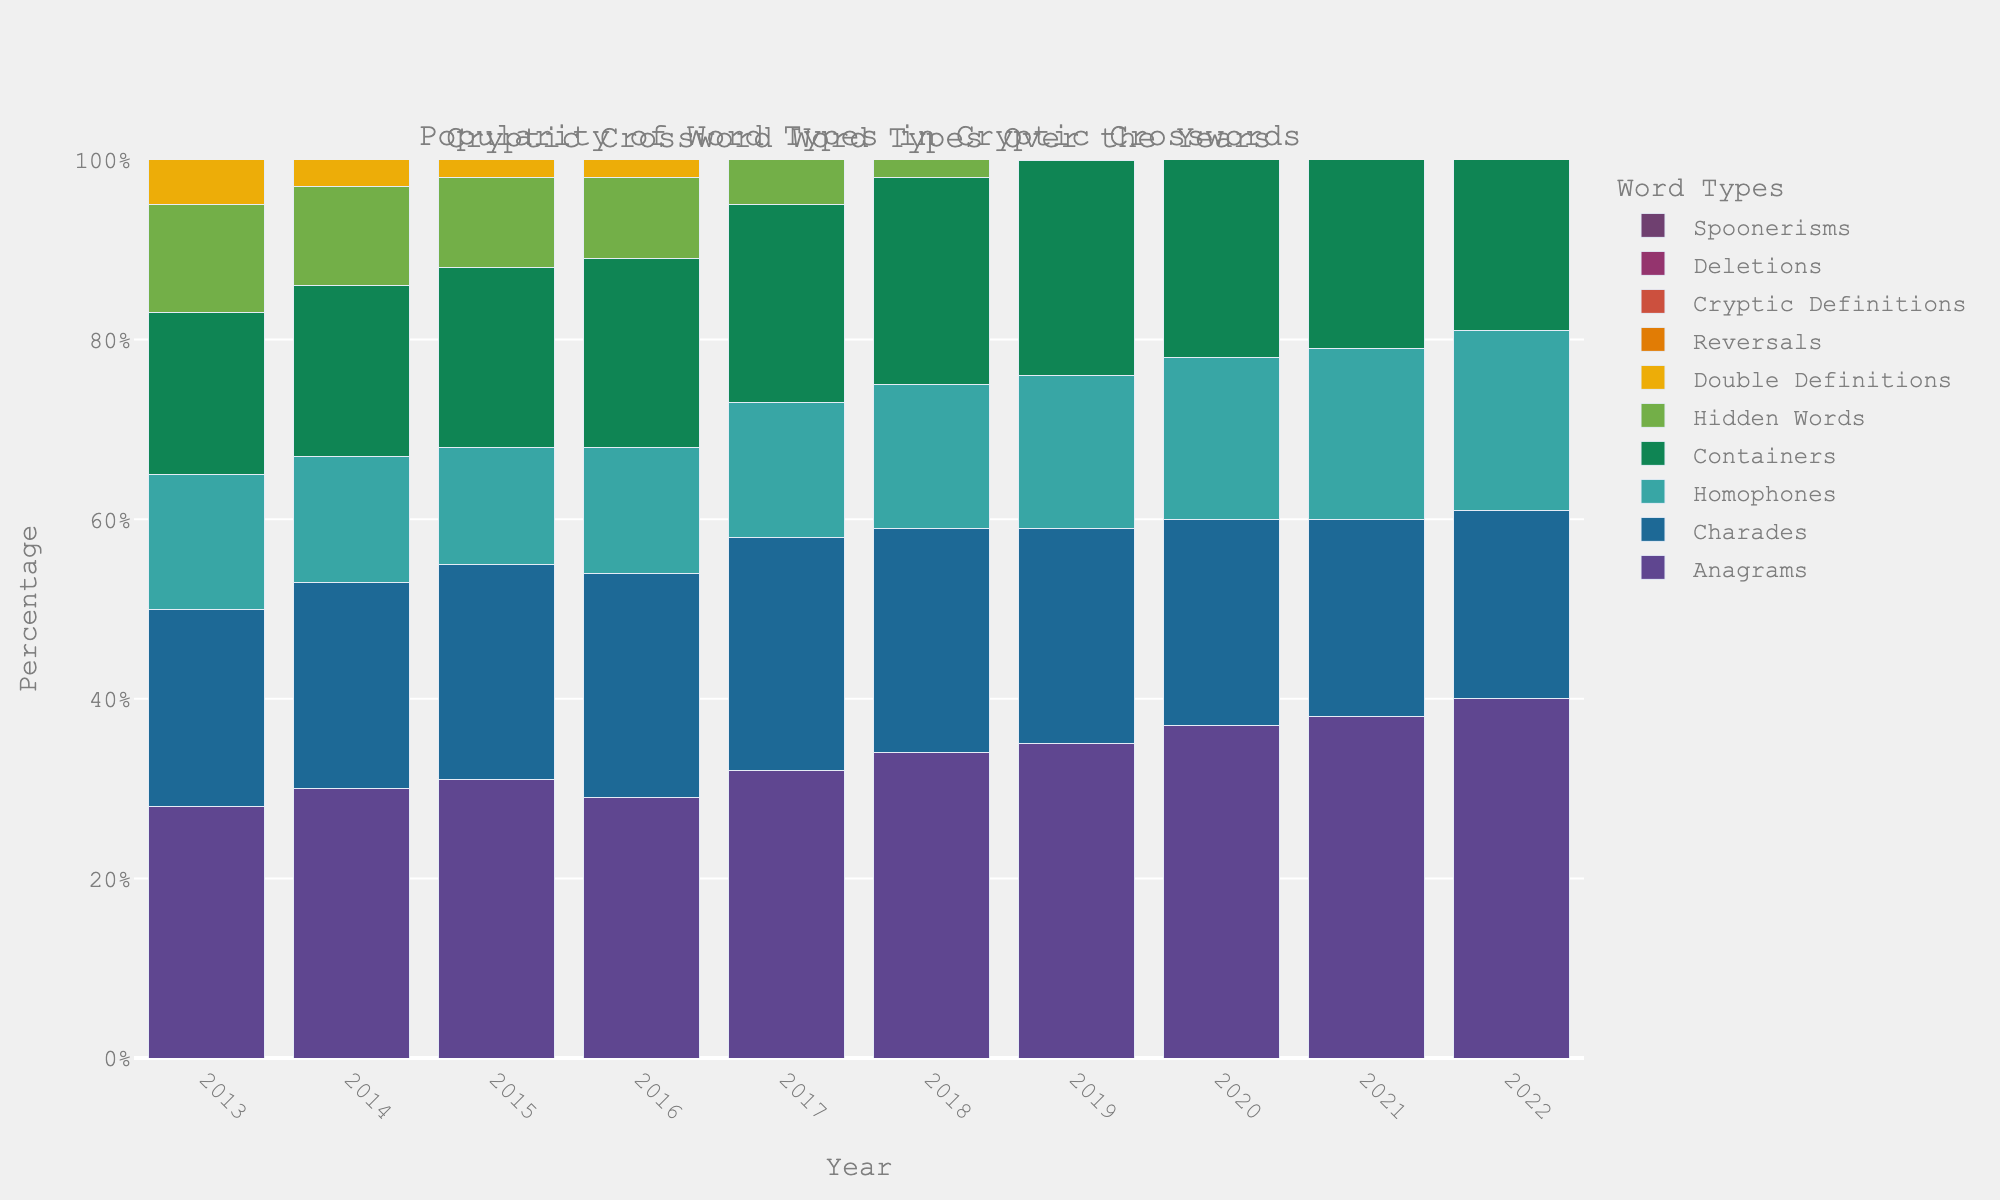What's the most popular word type in 2022? To determine the most popular word type in 2022, look for the bar with the greatest height for the year 2022. The bar for "Anagrams" is the tallest in 2022.
Answer: Anagrams Which word type has the least popularity in 2013? Look at the bars for the year 2013 and identify the one with the smallest height. "Spoonerisms" have the shortest bar in 2013.
Answer: Spoonerisms By how much did the popularity of "Hidden Words" decrease from 2013 to 2022? The percentage for "Hidden Words" in 2013 is 12%, and in 2022 it is 3%. The decrease is calculated as 12% - 3% = 9%.
Answer: 9% Comparing 2017, which word type increased the most by 2022? Look at the bars for both years, find the highest increase by subtracting the 2017 value from the 2022 value for each word type. "Anagrams" increased from 32 to 40, which is the highest increase of 8.
Answer: Anagrams What's the average popularity of "Charades" from 2013 to 2022? Calculate the average by summing the popularity percentages of "Charades" over the given years and dividing by the number of years. Sum: 22+23+24+25+26+25+24+23+22+21 = 235. Average = 235/10 = 23.5
Answer: 23.5 Which word type had a constant popularity from 2018 to 2022? Search for word types where the values from 2018 to 2022 are the same. All values for "Charades" from 2018 to 2022 are decreasing thus none of the word types have constant popularity.
Answer: None Which word type's popularity doubled from 2013 to 2022? Find all word types where the 2022 value is exactly double the 2013 value. "Deletions" went from 4% in 2013 to 13% in 2022 which is more than double but "Reversals" doubled from 7% to 16%.
Answer: Reversals What is the sum of the popularity percentages for "Homophones" and "Cryptic Definitions" in 2020? Sum the popularity of each word type for the year 2020. For "Homophones", it is 18%, and for "Cryptic Definitions" it is 12%. Thus, 18% + 12% = 30%.
Answer: 30% Which word type saw a continual increase every year from 2013 to 2022? Identify the word types that saw their popularity percentages grow every subsequent year without a decrease. "Anagrams" continuously increased from 28% in 2013 to 40% in 2022 without any drop.
Answer: Anagrams 